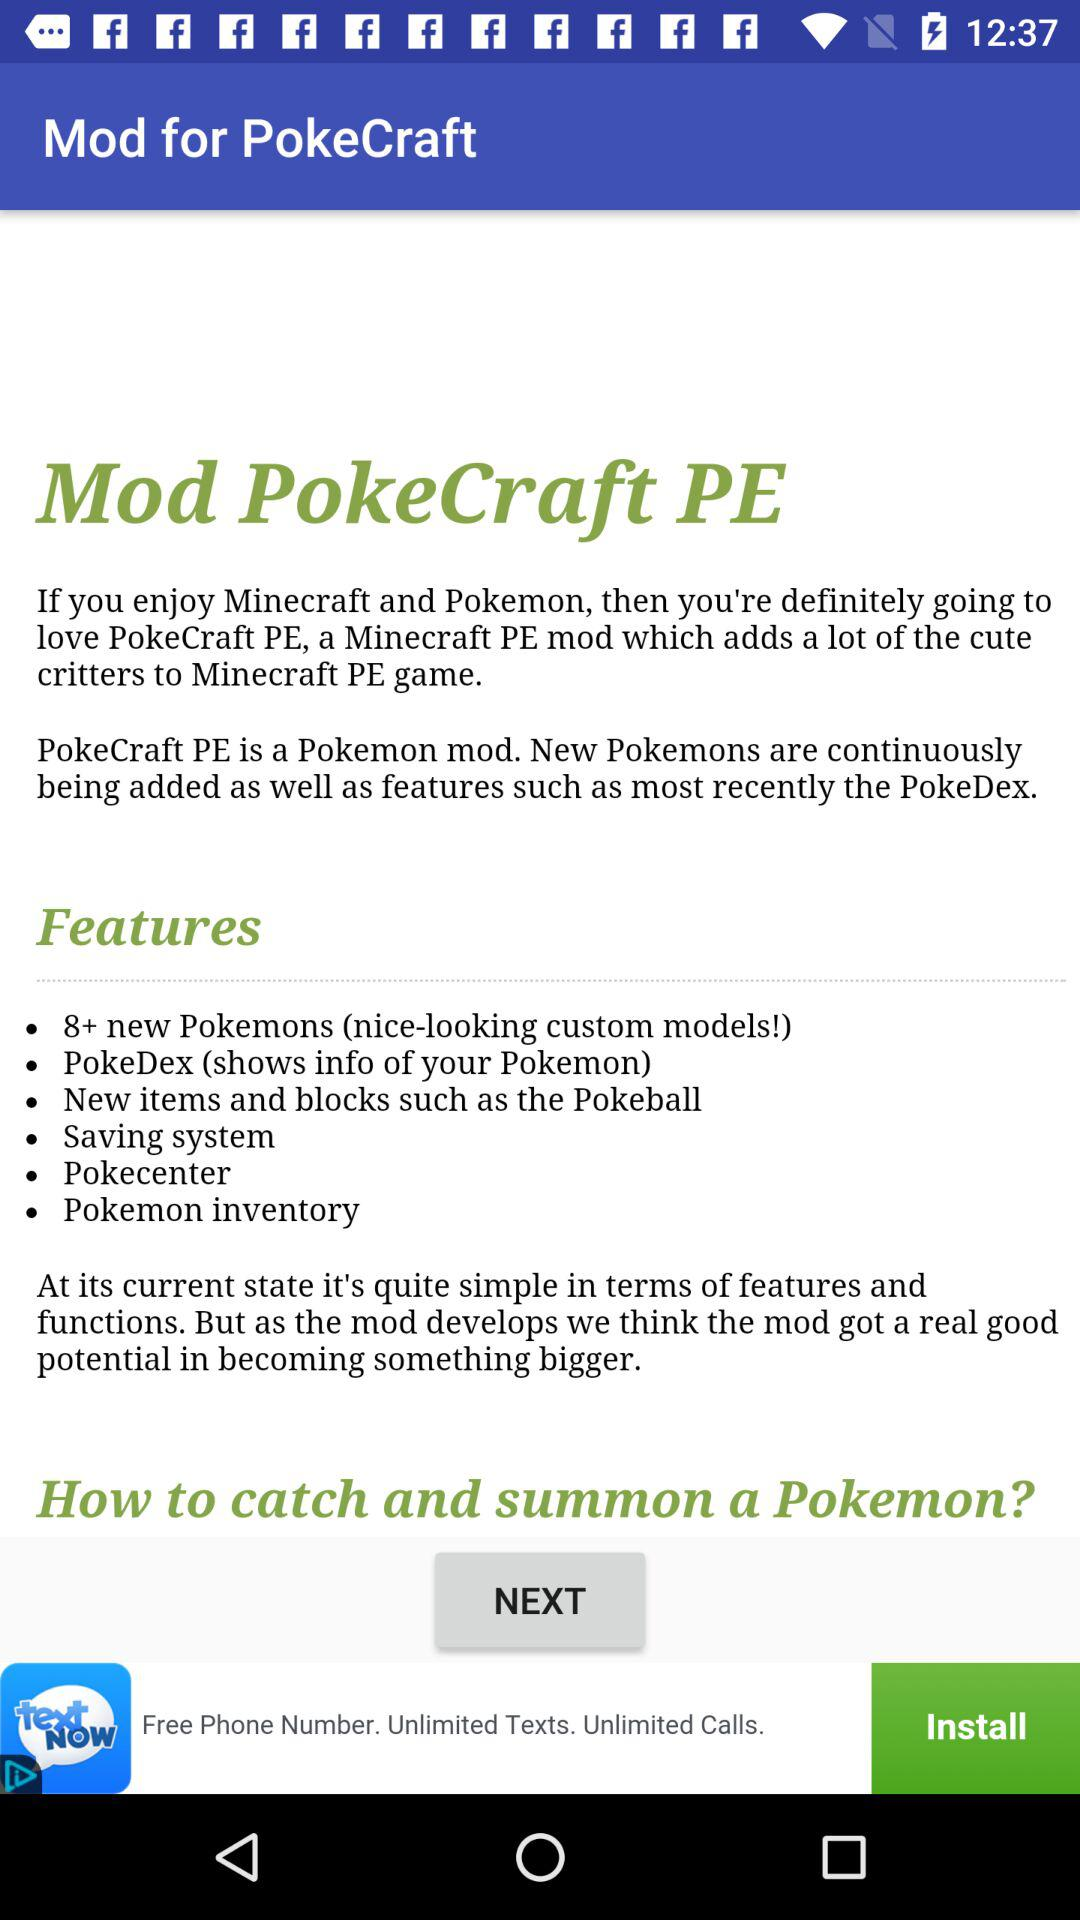How many new Pokemons are added? There are "8+" new Pokemons are added. 